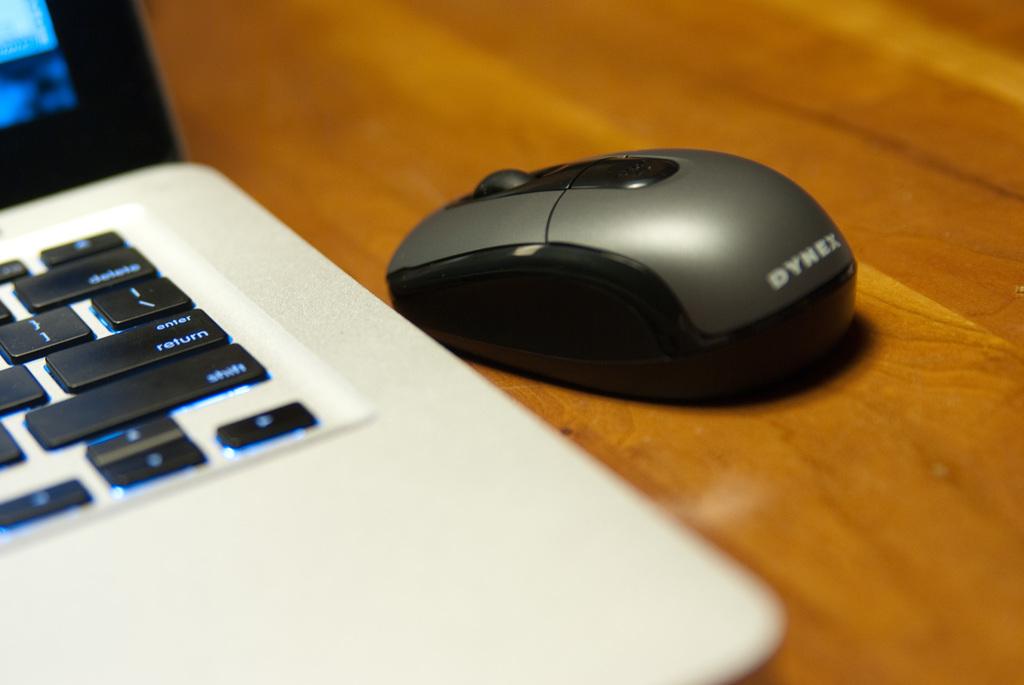What is the brand of the mouse?
Keep it short and to the point. Dynex. 